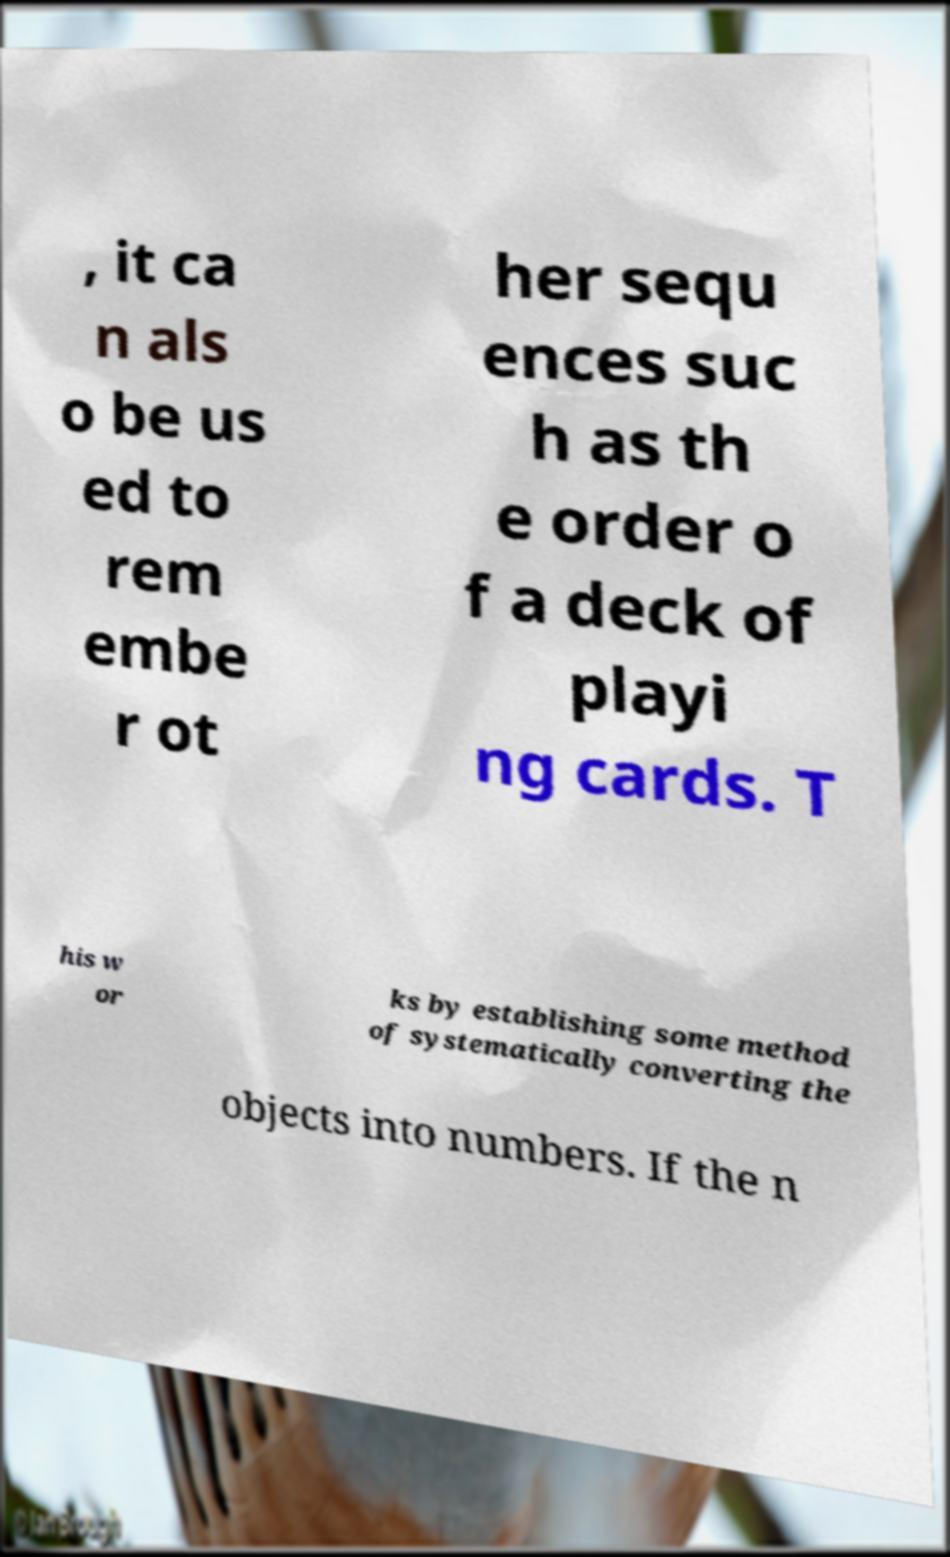Can you accurately transcribe the text from the provided image for me? , it ca n als o be us ed to rem embe r ot her sequ ences suc h as th e order o f a deck of playi ng cards. T his w or ks by establishing some method of systematically converting the objects into numbers. If the n 